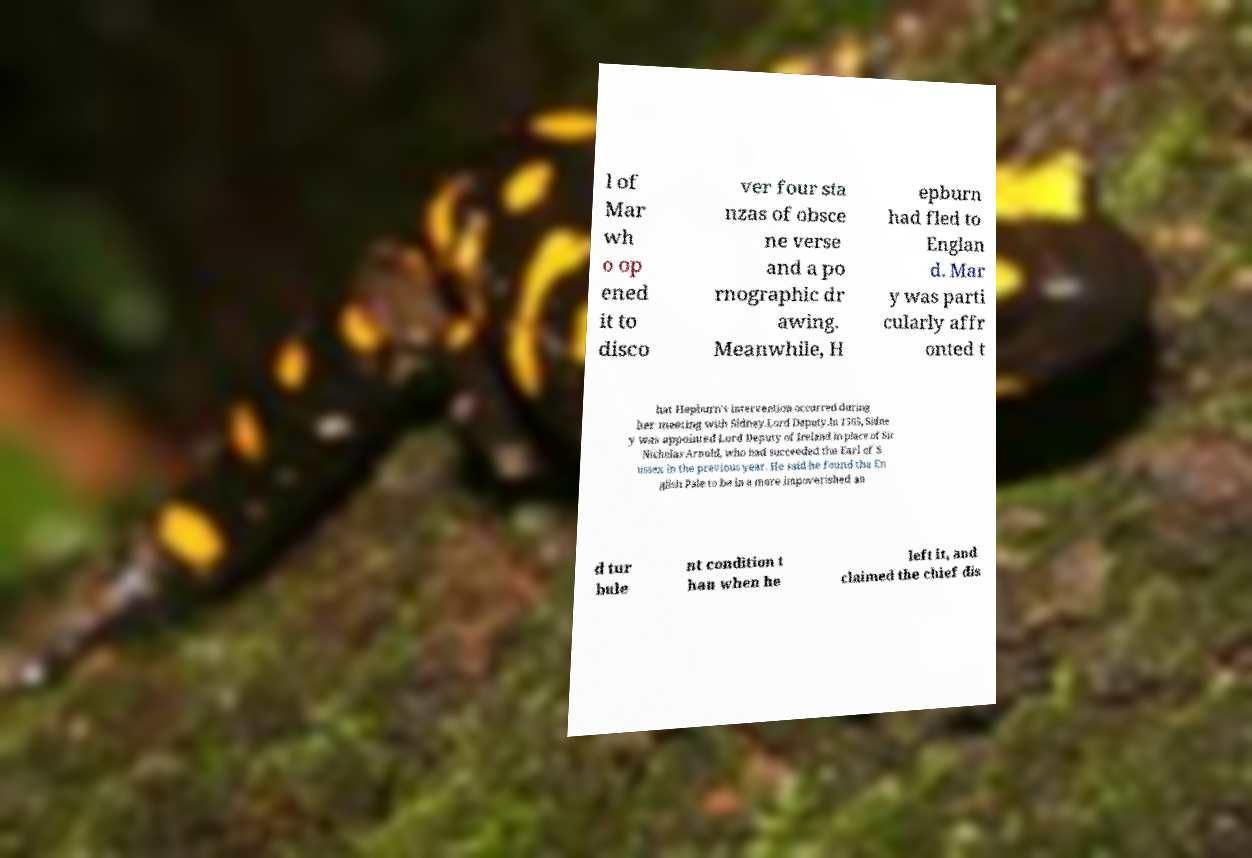I need the written content from this picture converted into text. Can you do that? l of Mar wh o op ened it to disco ver four sta nzas of obsce ne verse and a po rnographic dr awing. Meanwhile, H epburn had fled to Englan d. Mar y was parti cularly affr onted t hat Hepburn's intervention occurred during her meeting with Sidney.Lord Deputy.In 1565, Sidne y was appointed Lord Deputy of Ireland in place of Sir Nicholas Arnold, who had succeeded the Earl of S ussex in the previous year. He said he found the En glish Pale to be in a more impoverished an d tur bule nt condition t han when he left it, and claimed the chief dis 